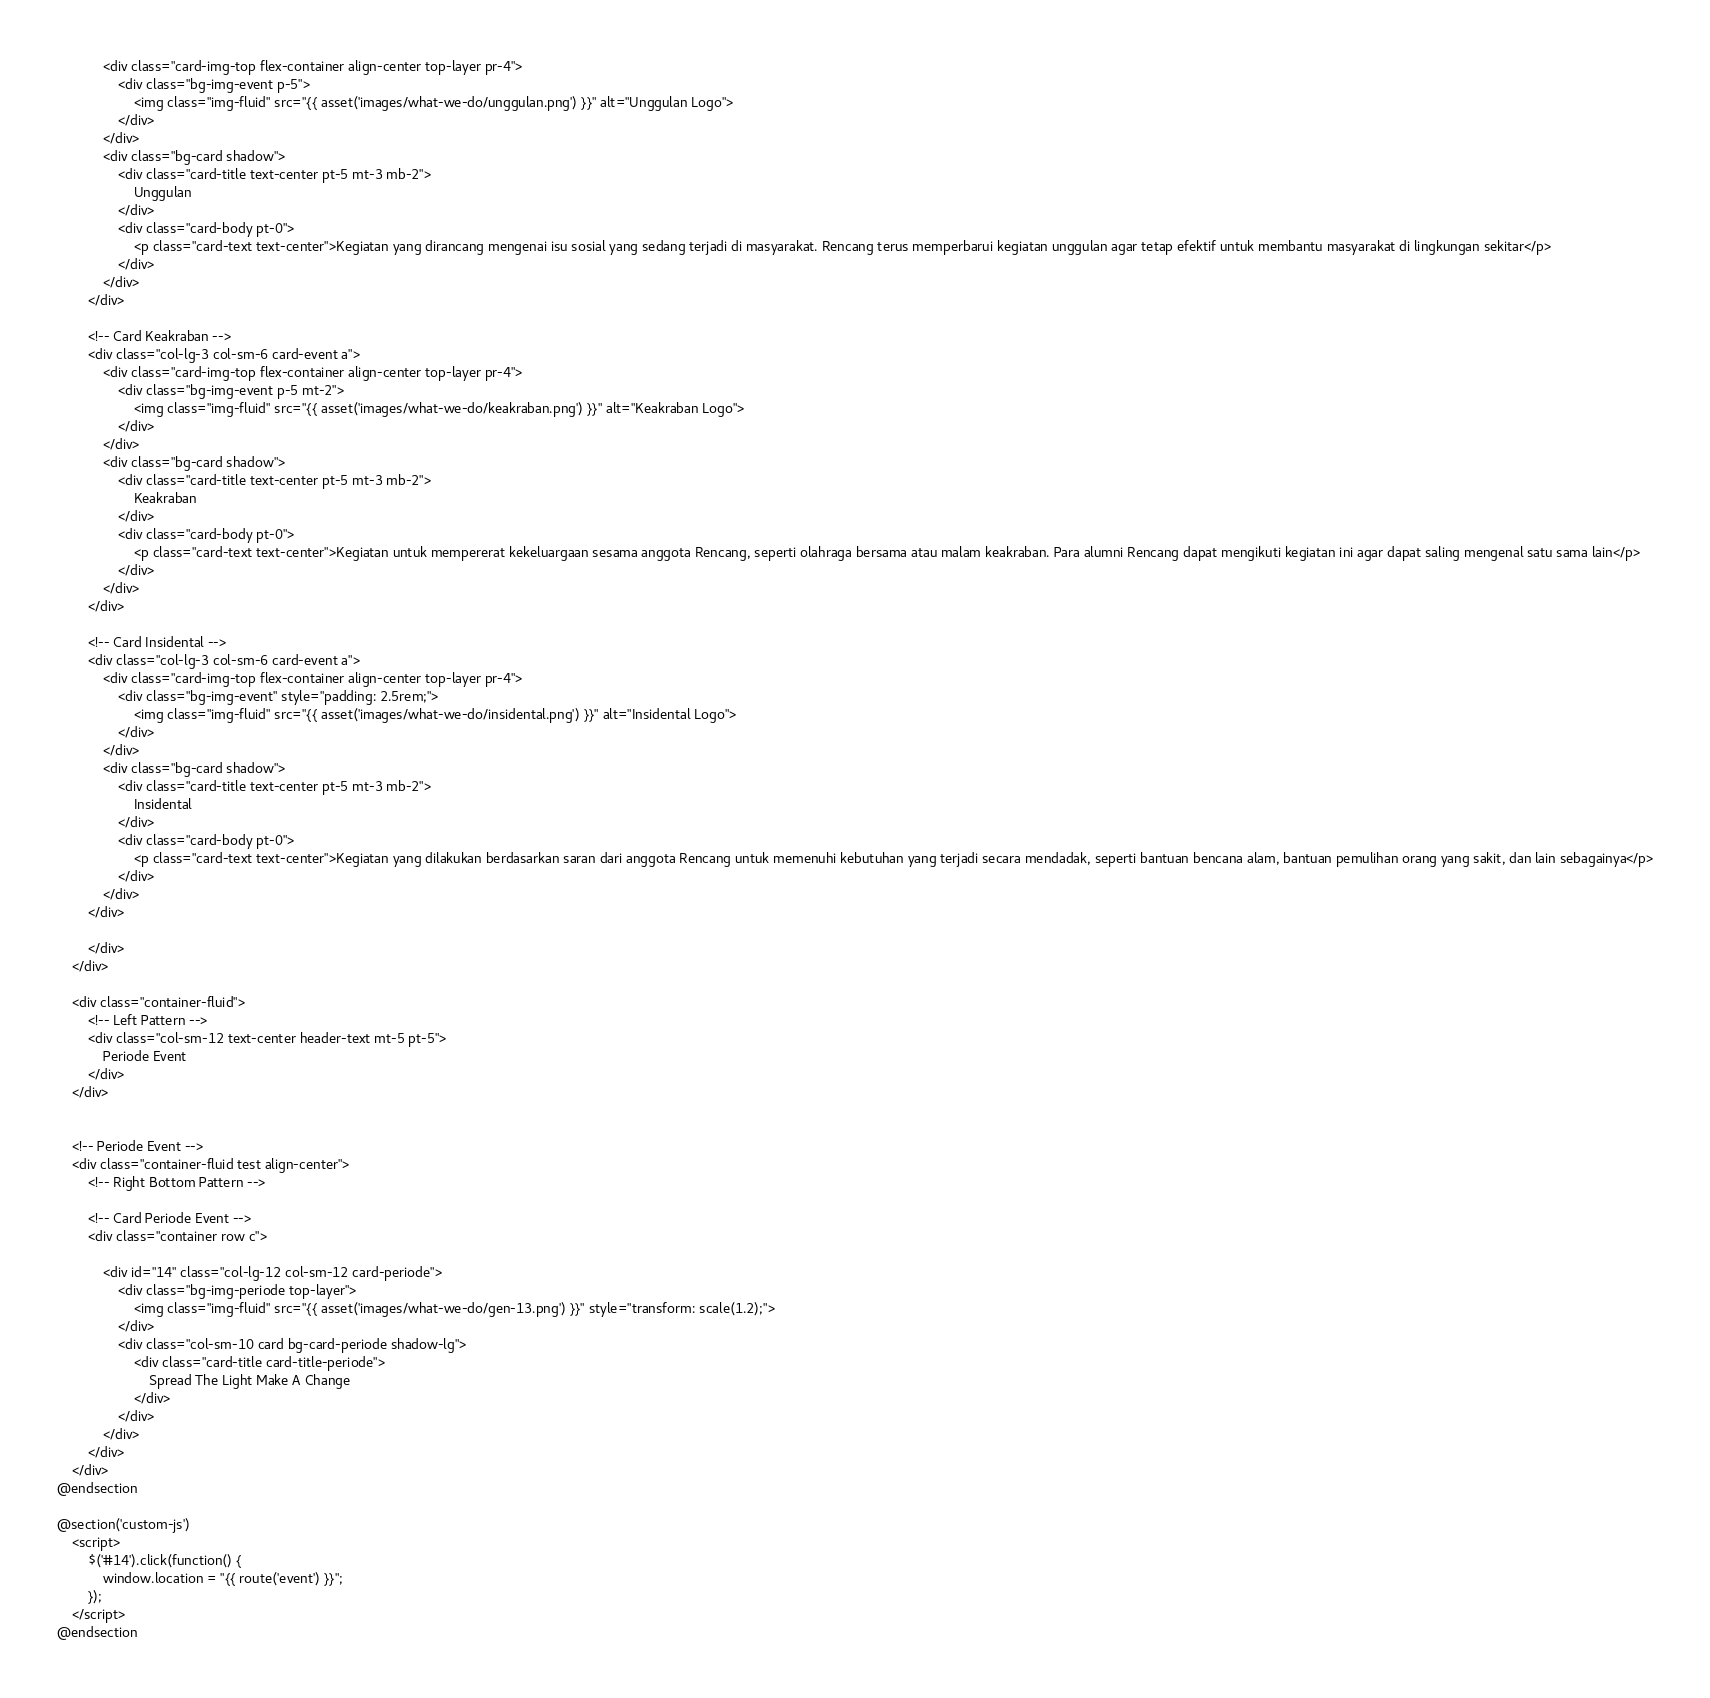Convert code to text. <code><loc_0><loc_0><loc_500><loc_500><_PHP_>            <div class="card-img-top flex-container align-center top-layer pr-4">
                <div class="bg-img-event p-5">
                    <img class="img-fluid" src="{{ asset('images/what-we-do/unggulan.png') }}" alt="Unggulan Logo">
                </div>
            </div>
            <div class="bg-card shadow">
                <div class="card-title text-center pt-5 mt-3 mb-2">
                    Unggulan
                </div>
                <div class="card-body pt-0">
                    <p class="card-text text-center">Kegiatan yang dirancang mengenai isu sosial yang sedang terjadi di masyarakat. Rencang terus memperbarui kegiatan unggulan agar tetap efektif untuk membantu masyarakat di lingkungan sekitar</p>
                </div>
            </div>
        </div>

        <!-- Card Keakraban -->
        <div class="col-lg-3 col-sm-6 card-event a">
            <div class="card-img-top flex-container align-center top-layer pr-4">
                <div class="bg-img-event p-5 mt-2">
                    <img class="img-fluid" src="{{ asset('images/what-we-do/keakraban.png') }}" alt="Keakraban Logo">
                </div>
            </div>
            <div class="bg-card shadow">
                <div class="card-title text-center pt-5 mt-3 mb-2">
                    Keakraban
                </div>
                <div class="card-body pt-0">
                    <p class="card-text text-center">Kegiatan untuk mempererat kekeluargaan sesama anggota Rencang, seperti olahraga bersama atau malam keakraban. Para alumni Rencang dapat mengikuti kegiatan ini agar dapat saling mengenal satu sama lain</p>
                </div>
            </div>
        </div>

        <!-- Card Insidental -->
        <div class="col-lg-3 col-sm-6 card-event a">
            <div class="card-img-top flex-container align-center top-layer pr-4">
                <div class="bg-img-event" style="padding: 2.5rem;">
                    <img class="img-fluid" src="{{ asset('images/what-we-do/insidental.png') }}" alt="Insidental Logo">
                </div>
            </div>
            <div class="bg-card shadow">
                <div class="card-title text-center pt-5 mt-3 mb-2">
                    Insidental
                </div>
                <div class="card-body pt-0">
                    <p class="card-text text-center">Kegiatan yang dilakukan berdasarkan saran dari anggota Rencang untuk memenuhi kebutuhan yang terjadi secara mendadak, seperti bantuan bencana alam, bantuan pemulihan orang yang sakit, dan lain sebagainya</p>
                </div>
            </div>
        </div>

        </div>
    </div>

    <div class="container-fluid">
        <!-- Left Pattern -->
        <div class="col-sm-12 text-center header-text mt-5 pt-5">
            Periode Event
        </div>
    </div>
    

    <!-- Periode Event -->
    <div class="container-fluid test align-center">
        <!-- Right Bottom Pattern -->

        <!-- Card Periode Event -->
        <div class="container row c">

            <div id="14" class="col-lg-12 col-sm-12 card-periode">
                <div class="bg-img-periode top-layer">
                    <img class="img-fluid" src="{{ asset('images/what-we-do/gen-13.png') }}" style="transform: scale(1.2);">
                </div>
                <div class="col-sm-10 card bg-card-periode shadow-lg">
                    <div class="card-title card-title-periode">
                        Spread The Light Make A Change 
                    </div>
                </div>
            </div>
        </div>
    </div>
@endsection

@section('custom-js')
    <script>
        $('#14').click(function() {
            window.location = "{{ route('event') }}";
        });
    </script>
@endsection</code> 